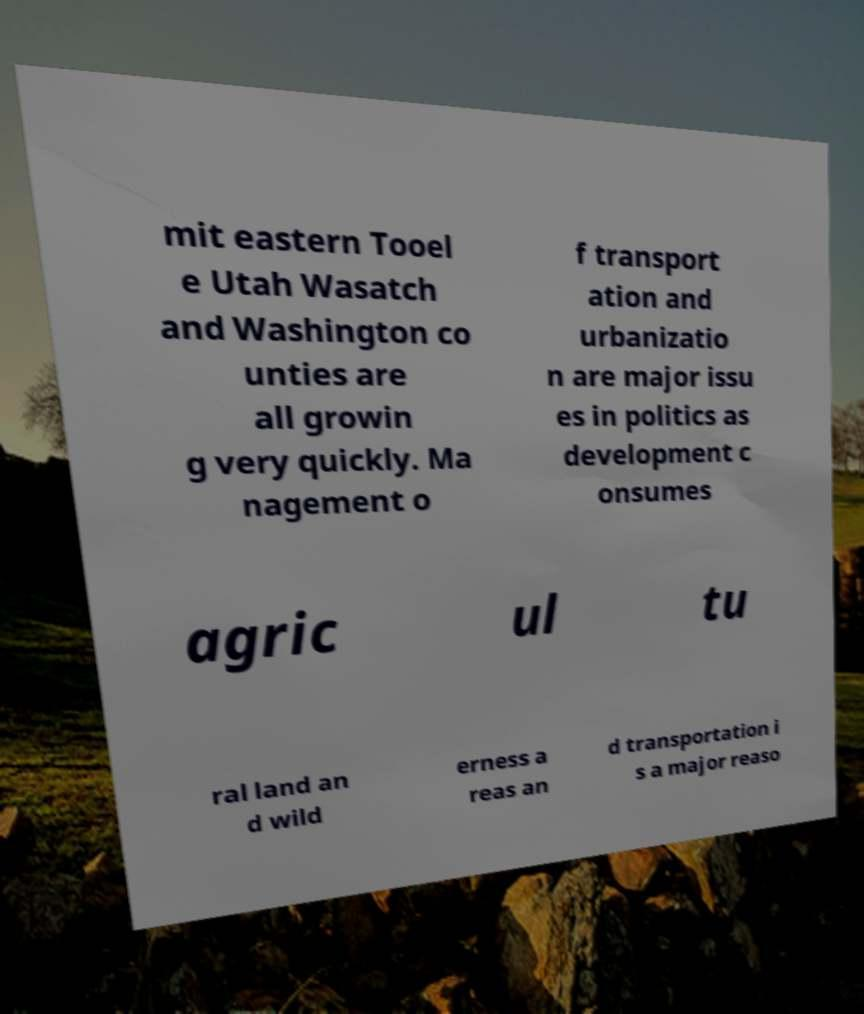Can you read and provide the text displayed in the image?This photo seems to have some interesting text. Can you extract and type it out for me? mit eastern Tooel e Utah Wasatch and Washington co unties are all growin g very quickly. Ma nagement o f transport ation and urbanizatio n are major issu es in politics as development c onsumes agric ul tu ral land an d wild erness a reas an d transportation i s a major reaso 